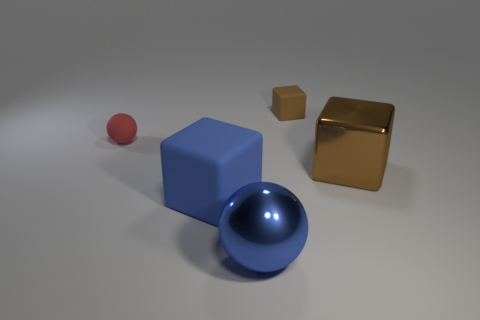Are there more small blocks that are in front of the rubber sphere than tiny red balls that are right of the tiny brown matte block?
Your response must be concise. No. There is a ball that is behind the metallic object behind the blue sphere; what color is it?
Your answer should be very brief. Red. How many spheres are either tiny brown objects or large blue things?
Offer a very short reply. 1. What number of blocks are both behind the large matte cube and on the left side of the brown metallic object?
Offer a very short reply. 1. What is the color of the large metal thing in front of the large blue cube?
Provide a succinct answer. Blue. There is a blue thing that is the same material as the red object; what is its size?
Make the answer very short. Large. There is a brown object left of the large brown shiny block; how many objects are behind it?
Offer a terse response. 0. There is a tiny red object; what number of metal cubes are right of it?
Your answer should be compact. 1. What is the color of the metallic thing on the right side of the small brown matte cube that is right of the rubber object that is on the left side of the large matte block?
Provide a succinct answer. Brown. Is the color of the block behind the red matte object the same as the shiny thing that is behind the big matte thing?
Your answer should be very brief. Yes. 